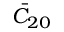Convert formula to latex. <formula><loc_0><loc_0><loc_500><loc_500>\bar { C } _ { 2 0 }</formula> 